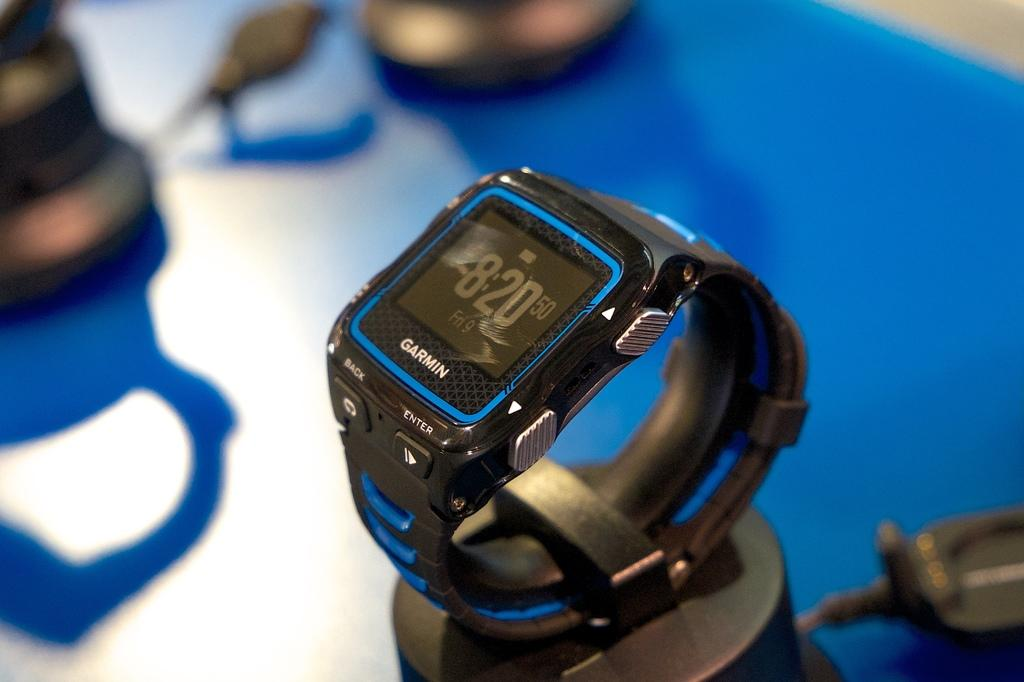<image>
Write a terse but informative summary of the picture. A Garmin watch shows the time as 8:20 on Friday the 9th. 